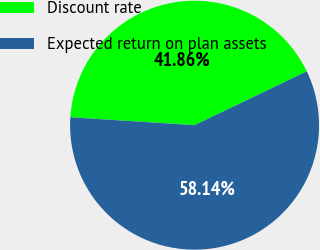<chart> <loc_0><loc_0><loc_500><loc_500><pie_chart><fcel>Discount rate<fcel>Expected return on plan assets<nl><fcel>41.86%<fcel>58.14%<nl></chart> 